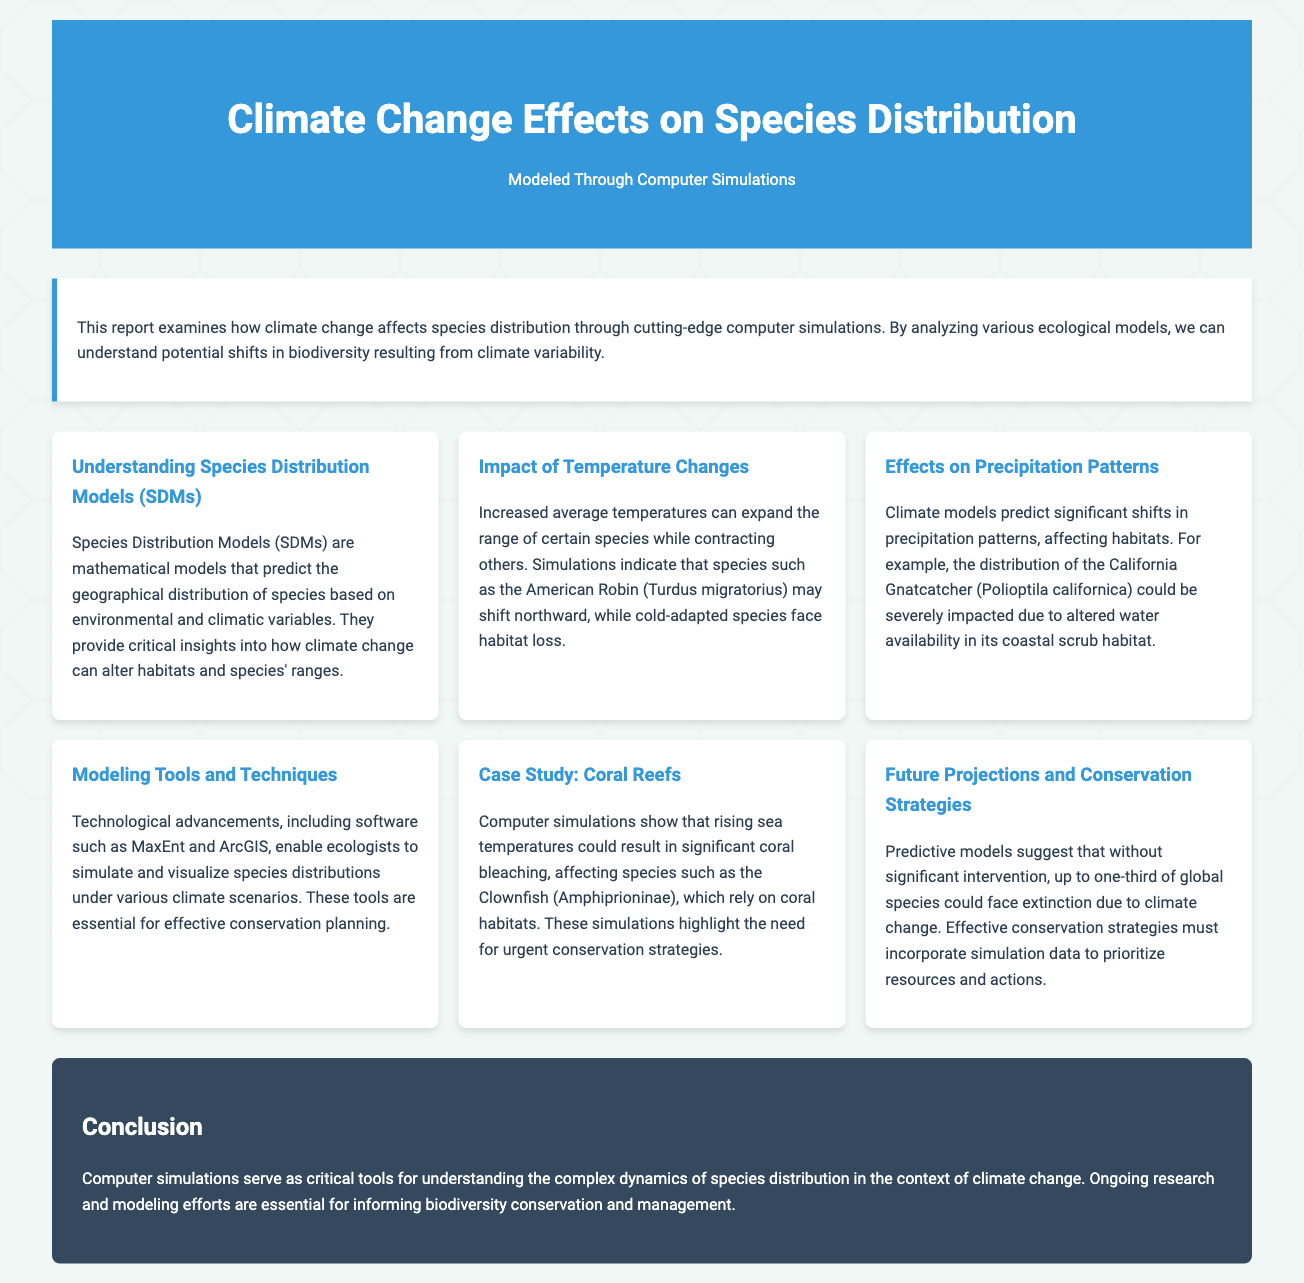what is the title of the report? The title can be found at the top of the document within the header section.
Answer: Climate Change Effects on Species Distribution what is the primary focus of the report? The primary focus is described in the introduction section of the document.
Answer: Effects of climate change on species distribution which bird species is mentioned as potentially shifting northward? This information is found in the section discussing temperature changes.
Answer: American Robin what impact do altered precipitation patterns have on the California Gnatcatcher? The effects on the California Gnatcatcher are addressed in the section about precipitation patterns.
Answer: Severely impacted due to altered water availability what technology is mentioned as essential for simulating species distributions? The technologies are discussed in the "Modeling Tools and Techniques" section of the document.
Answer: MaxEnt and ArcGIS how much of the global species could face extinction without intervention? This statistic is provided in the "Future Projections and Conservation Strategies" section.
Answer: Up to one-third what is a key conclusion drawn in the report? The conclusion summarizes the importance of the simulations as tools.
Answer: Critical tools for understanding species distribution which group of species relies on coral habitats? This information is highlighted in the "Case Study: Coral Reefs" section.
Answer: Clownfish 